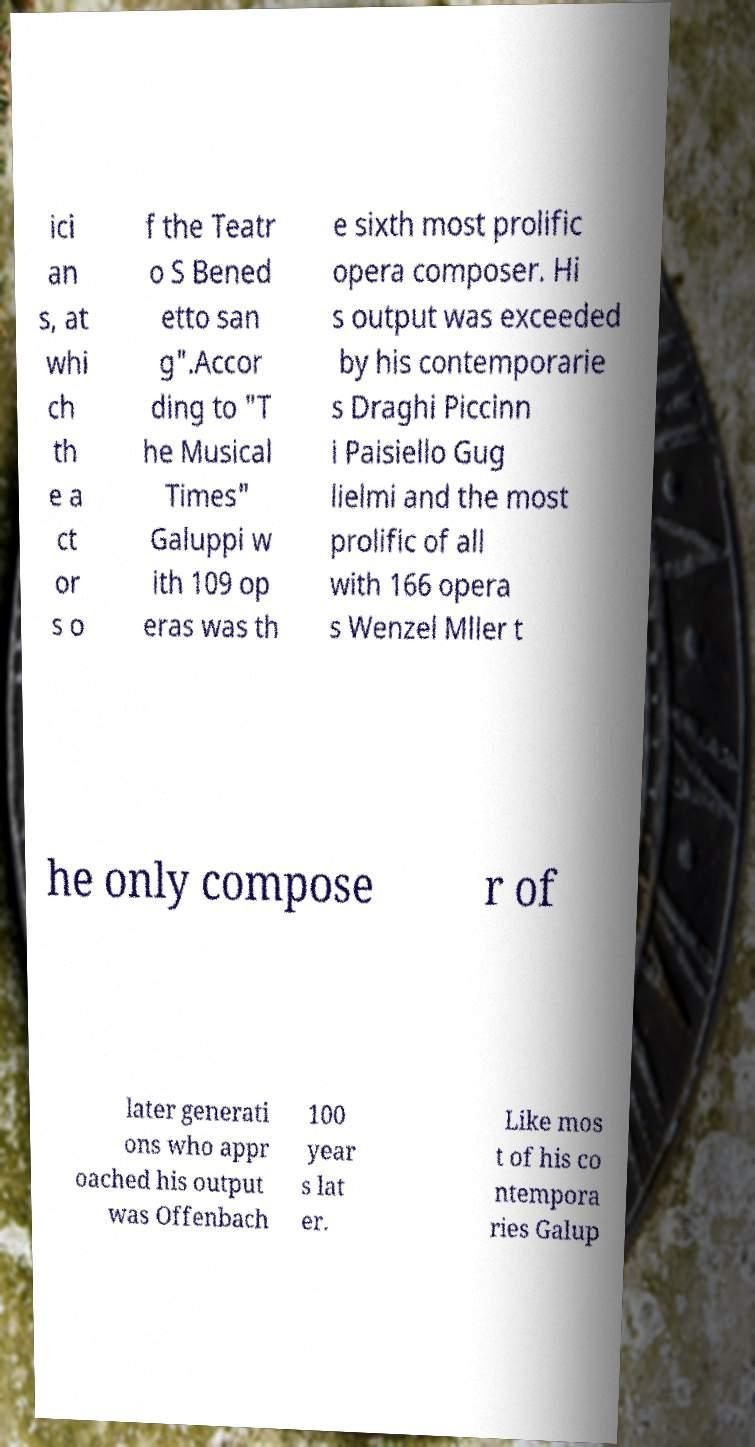Can you accurately transcribe the text from the provided image for me? ici an s, at whi ch th e a ct or s o f the Teatr o S Bened etto san g".Accor ding to "T he Musical Times" Galuppi w ith 109 op eras was th e sixth most prolific opera composer. Hi s output was exceeded by his contemporarie s Draghi Piccinn i Paisiello Gug lielmi and the most prolific of all with 166 opera s Wenzel Mller t he only compose r of later generati ons who appr oached his output was Offenbach 100 year s lat er. Like mos t of his co ntempora ries Galup 